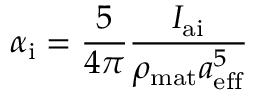<formula> <loc_0><loc_0><loc_500><loc_500>\alpha _ { i } = \frac { 5 } { 4 \pi } \frac { I _ { a i } } { \rho _ { m a t } a _ { e f f } ^ { 5 } }</formula> 